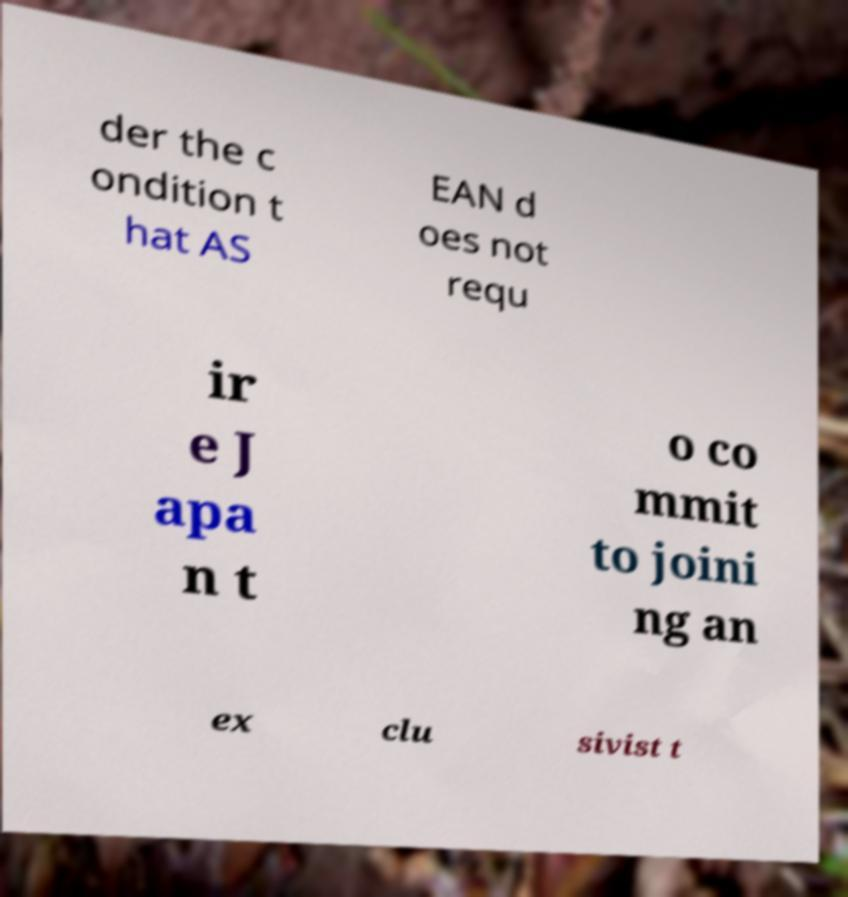What messages or text are displayed in this image? I need them in a readable, typed format. der the c ondition t hat AS EAN d oes not requ ir e J apa n t o co mmit to joini ng an ex clu sivist t 